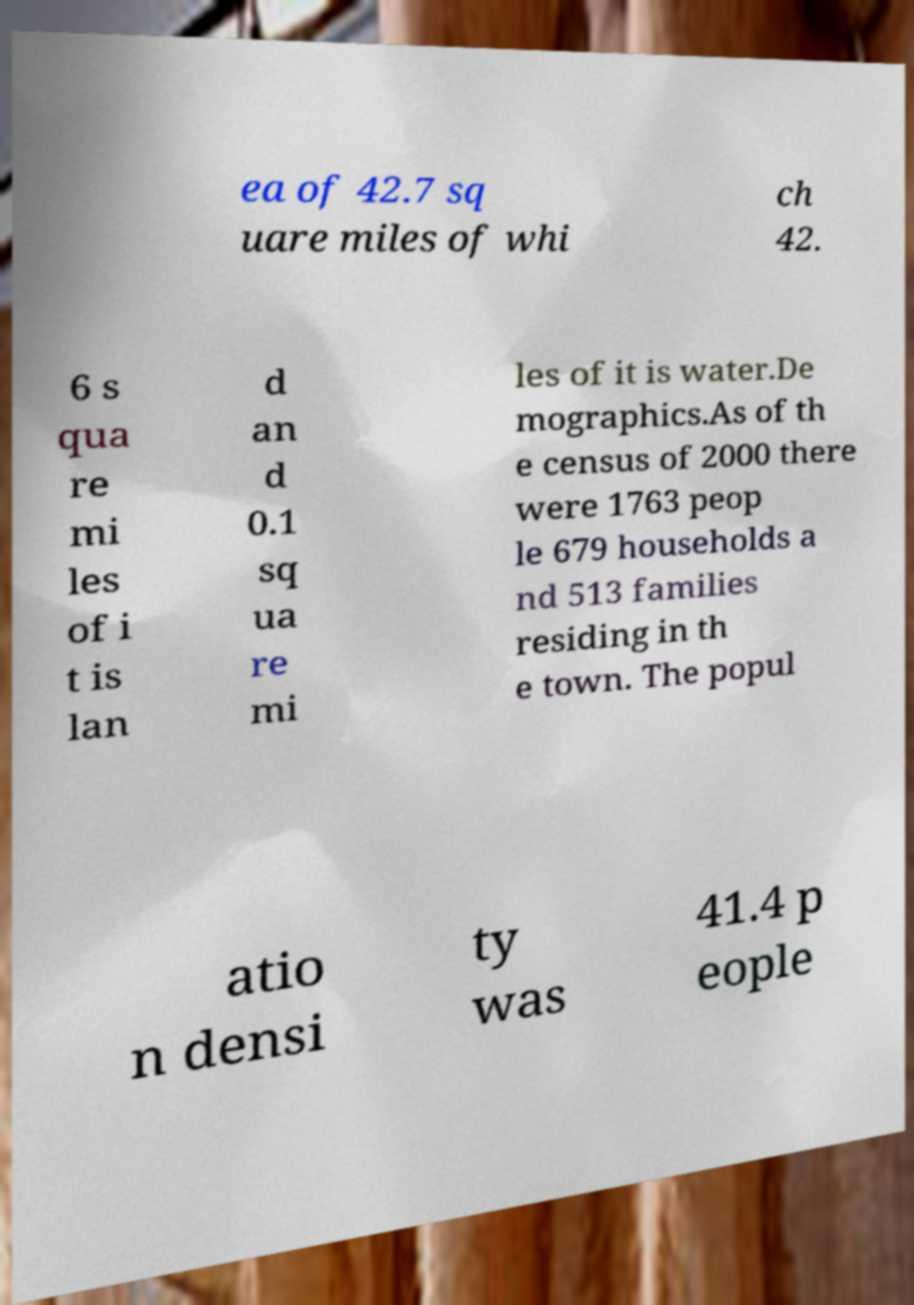Can you accurately transcribe the text from the provided image for me? ea of 42.7 sq uare miles of whi ch 42. 6 s qua re mi les of i t is lan d an d 0.1 sq ua re mi les of it is water.De mographics.As of th e census of 2000 there were 1763 peop le 679 households a nd 513 families residing in th e town. The popul atio n densi ty was 41.4 p eople 